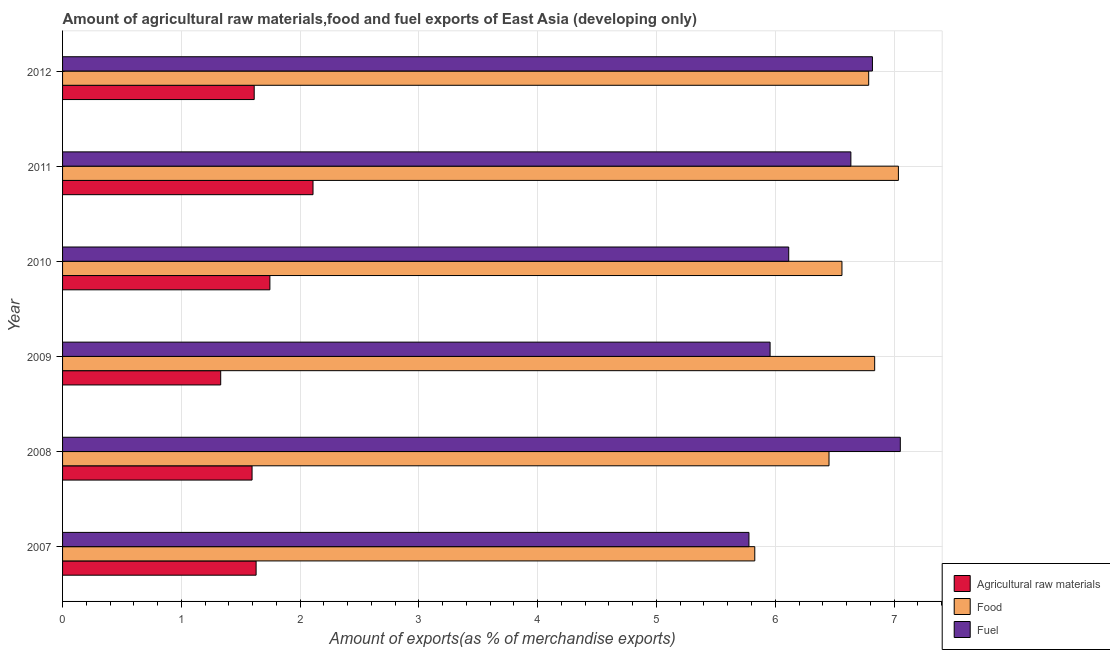How many different coloured bars are there?
Your answer should be very brief. 3. Are the number of bars per tick equal to the number of legend labels?
Offer a terse response. Yes. How many bars are there on the 6th tick from the top?
Your answer should be very brief. 3. In how many cases, is the number of bars for a given year not equal to the number of legend labels?
Offer a very short reply. 0. What is the percentage of raw materials exports in 2009?
Your answer should be compact. 1.33. Across all years, what is the maximum percentage of raw materials exports?
Your response must be concise. 2.11. Across all years, what is the minimum percentage of raw materials exports?
Your answer should be very brief. 1.33. In which year was the percentage of food exports minimum?
Keep it short and to the point. 2007. What is the total percentage of food exports in the graph?
Provide a succinct answer. 39.5. What is the difference between the percentage of food exports in 2010 and the percentage of fuel exports in 2012?
Ensure brevity in your answer.  -0.26. What is the average percentage of fuel exports per year?
Make the answer very short. 6.39. In the year 2012, what is the difference between the percentage of fuel exports and percentage of raw materials exports?
Offer a very short reply. 5.21. What is the ratio of the percentage of food exports in 2008 to that in 2009?
Keep it short and to the point. 0.94. Is the percentage of fuel exports in 2008 less than that in 2012?
Your response must be concise. No. What is the difference between the highest and the second highest percentage of fuel exports?
Your answer should be very brief. 0.23. What is the difference between the highest and the lowest percentage of raw materials exports?
Offer a very short reply. 0.78. Is the sum of the percentage of food exports in 2008 and 2012 greater than the maximum percentage of fuel exports across all years?
Your answer should be very brief. Yes. What does the 3rd bar from the top in 2012 represents?
Offer a terse response. Agricultural raw materials. What does the 1st bar from the bottom in 2007 represents?
Give a very brief answer. Agricultural raw materials. How many bars are there?
Offer a very short reply. 18. Are all the bars in the graph horizontal?
Keep it short and to the point. Yes. What is the difference between two consecutive major ticks on the X-axis?
Provide a succinct answer. 1. Are the values on the major ticks of X-axis written in scientific E-notation?
Offer a terse response. No. Where does the legend appear in the graph?
Keep it short and to the point. Bottom right. How many legend labels are there?
Give a very brief answer. 3. How are the legend labels stacked?
Your answer should be very brief. Vertical. What is the title of the graph?
Your answer should be very brief. Amount of agricultural raw materials,food and fuel exports of East Asia (developing only). What is the label or title of the X-axis?
Offer a terse response. Amount of exports(as % of merchandise exports). What is the Amount of exports(as % of merchandise exports) in Agricultural raw materials in 2007?
Offer a very short reply. 1.63. What is the Amount of exports(as % of merchandise exports) of Food in 2007?
Provide a short and direct response. 5.83. What is the Amount of exports(as % of merchandise exports) in Fuel in 2007?
Your response must be concise. 5.78. What is the Amount of exports(as % of merchandise exports) in Agricultural raw materials in 2008?
Provide a succinct answer. 1.6. What is the Amount of exports(as % of merchandise exports) in Food in 2008?
Keep it short and to the point. 6.45. What is the Amount of exports(as % of merchandise exports) of Fuel in 2008?
Ensure brevity in your answer.  7.05. What is the Amount of exports(as % of merchandise exports) in Agricultural raw materials in 2009?
Your response must be concise. 1.33. What is the Amount of exports(as % of merchandise exports) in Food in 2009?
Make the answer very short. 6.84. What is the Amount of exports(as % of merchandise exports) of Fuel in 2009?
Offer a terse response. 5.96. What is the Amount of exports(as % of merchandise exports) in Agricultural raw materials in 2010?
Give a very brief answer. 1.75. What is the Amount of exports(as % of merchandise exports) in Food in 2010?
Your answer should be very brief. 6.56. What is the Amount of exports(as % of merchandise exports) of Fuel in 2010?
Keep it short and to the point. 6.11. What is the Amount of exports(as % of merchandise exports) of Agricultural raw materials in 2011?
Ensure brevity in your answer.  2.11. What is the Amount of exports(as % of merchandise exports) of Food in 2011?
Provide a short and direct response. 7.04. What is the Amount of exports(as % of merchandise exports) in Fuel in 2011?
Your answer should be very brief. 6.64. What is the Amount of exports(as % of merchandise exports) in Agricultural raw materials in 2012?
Keep it short and to the point. 1.61. What is the Amount of exports(as % of merchandise exports) of Food in 2012?
Keep it short and to the point. 6.79. What is the Amount of exports(as % of merchandise exports) in Fuel in 2012?
Make the answer very short. 6.82. Across all years, what is the maximum Amount of exports(as % of merchandise exports) in Agricultural raw materials?
Offer a very short reply. 2.11. Across all years, what is the maximum Amount of exports(as % of merchandise exports) in Food?
Provide a short and direct response. 7.04. Across all years, what is the maximum Amount of exports(as % of merchandise exports) of Fuel?
Offer a very short reply. 7.05. Across all years, what is the minimum Amount of exports(as % of merchandise exports) in Agricultural raw materials?
Your answer should be very brief. 1.33. Across all years, what is the minimum Amount of exports(as % of merchandise exports) in Food?
Keep it short and to the point. 5.83. Across all years, what is the minimum Amount of exports(as % of merchandise exports) in Fuel?
Offer a very short reply. 5.78. What is the total Amount of exports(as % of merchandise exports) of Agricultural raw materials in the graph?
Make the answer very short. 10.02. What is the total Amount of exports(as % of merchandise exports) in Food in the graph?
Your response must be concise. 39.5. What is the total Amount of exports(as % of merchandise exports) in Fuel in the graph?
Your answer should be very brief. 38.36. What is the difference between the Amount of exports(as % of merchandise exports) in Agricultural raw materials in 2007 and that in 2008?
Provide a short and direct response. 0.03. What is the difference between the Amount of exports(as % of merchandise exports) of Food in 2007 and that in 2008?
Make the answer very short. -0.62. What is the difference between the Amount of exports(as % of merchandise exports) in Fuel in 2007 and that in 2008?
Your response must be concise. -1.27. What is the difference between the Amount of exports(as % of merchandise exports) in Agricultural raw materials in 2007 and that in 2009?
Keep it short and to the point. 0.3. What is the difference between the Amount of exports(as % of merchandise exports) in Food in 2007 and that in 2009?
Give a very brief answer. -1.01. What is the difference between the Amount of exports(as % of merchandise exports) in Fuel in 2007 and that in 2009?
Offer a terse response. -0.18. What is the difference between the Amount of exports(as % of merchandise exports) in Agricultural raw materials in 2007 and that in 2010?
Keep it short and to the point. -0.12. What is the difference between the Amount of exports(as % of merchandise exports) in Food in 2007 and that in 2010?
Offer a terse response. -0.73. What is the difference between the Amount of exports(as % of merchandise exports) in Fuel in 2007 and that in 2010?
Provide a short and direct response. -0.33. What is the difference between the Amount of exports(as % of merchandise exports) of Agricultural raw materials in 2007 and that in 2011?
Your response must be concise. -0.48. What is the difference between the Amount of exports(as % of merchandise exports) in Food in 2007 and that in 2011?
Provide a short and direct response. -1.21. What is the difference between the Amount of exports(as % of merchandise exports) in Fuel in 2007 and that in 2011?
Make the answer very short. -0.86. What is the difference between the Amount of exports(as % of merchandise exports) in Agricultural raw materials in 2007 and that in 2012?
Give a very brief answer. 0.02. What is the difference between the Amount of exports(as % of merchandise exports) of Food in 2007 and that in 2012?
Your answer should be compact. -0.96. What is the difference between the Amount of exports(as % of merchandise exports) of Fuel in 2007 and that in 2012?
Keep it short and to the point. -1.04. What is the difference between the Amount of exports(as % of merchandise exports) in Agricultural raw materials in 2008 and that in 2009?
Your answer should be compact. 0.26. What is the difference between the Amount of exports(as % of merchandise exports) of Food in 2008 and that in 2009?
Your answer should be compact. -0.38. What is the difference between the Amount of exports(as % of merchandise exports) of Fuel in 2008 and that in 2009?
Provide a succinct answer. 1.1. What is the difference between the Amount of exports(as % of merchandise exports) in Agricultural raw materials in 2008 and that in 2010?
Your answer should be compact. -0.15. What is the difference between the Amount of exports(as % of merchandise exports) in Food in 2008 and that in 2010?
Offer a terse response. -0.11. What is the difference between the Amount of exports(as % of merchandise exports) of Fuel in 2008 and that in 2010?
Offer a very short reply. 0.94. What is the difference between the Amount of exports(as % of merchandise exports) of Agricultural raw materials in 2008 and that in 2011?
Provide a short and direct response. -0.51. What is the difference between the Amount of exports(as % of merchandise exports) in Food in 2008 and that in 2011?
Offer a terse response. -0.58. What is the difference between the Amount of exports(as % of merchandise exports) of Fuel in 2008 and that in 2011?
Offer a very short reply. 0.42. What is the difference between the Amount of exports(as % of merchandise exports) in Agricultural raw materials in 2008 and that in 2012?
Your answer should be very brief. -0.02. What is the difference between the Amount of exports(as % of merchandise exports) of Food in 2008 and that in 2012?
Keep it short and to the point. -0.33. What is the difference between the Amount of exports(as % of merchandise exports) in Fuel in 2008 and that in 2012?
Provide a succinct answer. 0.23. What is the difference between the Amount of exports(as % of merchandise exports) in Agricultural raw materials in 2009 and that in 2010?
Your answer should be very brief. -0.41. What is the difference between the Amount of exports(as % of merchandise exports) of Food in 2009 and that in 2010?
Your answer should be compact. 0.28. What is the difference between the Amount of exports(as % of merchandise exports) in Fuel in 2009 and that in 2010?
Provide a succinct answer. -0.16. What is the difference between the Amount of exports(as % of merchandise exports) of Agricultural raw materials in 2009 and that in 2011?
Your response must be concise. -0.78. What is the difference between the Amount of exports(as % of merchandise exports) of Food in 2009 and that in 2011?
Give a very brief answer. -0.2. What is the difference between the Amount of exports(as % of merchandise exports) in Fuel in 2009 and that in 2011?
Your answer should be very brief. -0.68. What is the difference between the Amount of exports(as % of merchandise exports) of Agricultural raw materials in 2009 and that in 2012?
Offer a very short reply. -0.28. What is the difference between the Amount of exports(as % of merchandise exports) in Food in 2009 and that in 2012?
Your answer should be very brief. 0.05. What is the difference between the Amount of exports(as % of merchandise exports) of Fuel in 2009 and that in 2012?
Keep it short and to the point. -0.86. What is the difference between the Amount of exports(as % of merchandise exports) of Agricultural raw materials in 2010 and that in 2011?
Your response must be concise. -0.36. What is the difference between the Amount of exports(as % of merchandise exports) of Food in 2010 and that in 2011?
Provide a succinct answer. -0.48. What is the difference between the Amount of exports(as % of merchandise exports) in Fuel in 2010 and that in 2011?
Give a very brief answer. -0.52. What is the difference between the Amount of exports(as % of merchandise exports) in Agricultural raw materials in 2010 and that in 2012?
Your answer should be compact. 0.13. What is the difference between the Amount of exports(as % of merchandise exports) in Food in 2010 and that in 2012?
Your answer should be compact. -0.23. What is the difference between the Amount of exports(as % of merchandise exports) in Fuel in 2010 and that in 2012?
Provide a short and direct response. -0.7. What is the difference between the Amount of exports(as % of merchandise exports) of Agricultural raw materials in 2011 and that in 2012?
Offer a terse response. 0.5. What is the difference between the Amount of exports(as % of merchandise exports) in Food in 2011 and that in 2012?
Your response must be concise. 0.25. What is the difference between the Amount of exports(as % of merchandise exports) of Fuel in 2011 and that in 2012?
Your answer should be compact. -0.18. What is the difference between the Amount of exports(as % of merchandise exports) in Agricultural raw materials in 2007 and the Amount of exports(as % of merchandise exports) in Food in 2008?
Provide a succinct answer. -4.82. What is the difference between the Amount of exports(as % of merchandise exports) of Agricultural raw materials in 2007 and the Amount of exports(as % of merchandise exports) of Fuel in 2008?
Your response must be concise. -5.42. What is the difference between the Amount of exports(as % of merchandise exports) of Food in 2007 and the Amount of exports(as % of merchandise exports) of Fuel in 2008?
Offer a very short reply. -1.23. What is the difference between the Amount of exports(as % of merchandise exports) in Agricultural raw materials in 2007 and the Amount of exports(as % of merchandise exports) in Food in 2009?
Provide a succinct answer. -5.21. What is the difference between the Amount of exports(as % of merchandise exports) of Agricultural raw materials in 2007 and the Amount of exports(as % of merchandise exports) of Fuel in 2009?
Provide a short and direct response. -4.33. What is the difference between the Amount of exports(as % of merchandise exports) of Food in 2007 and the Amount of exports(as % of merchandise exports) of Fuel in 2009?
Offer a very short reply. -0.13. What is the difference between the Amount of exports(as % of merchandise exports) in Agricultural raw materials in 2007 and the Amount of exports(as % of merchandise exports) in Food in 2010?
Provide a short and direct response. -4.93. What is the difference between the Amount of exports(as % of merchandise exports) of Agricultural raw materials in 2007 and the Amount of exports(as % of merchandise exports) of Fuel in 2010?
Make the answer very short. -4.48. What is the difference between the Amount of exports(as % of merchandise exports) of Food in 2007 and the Amount of exports(as % of merchandise exports) of Fuel in 2010?
Give a very brief answer. -0.29. What is the difference between the Amount of exports(as % of merchandise exports) of Agricultural raw materials in 2007 and the Amount of exports(as % of merchandise exports) of Food in 2011?
Ensure brevity in your answer.  -5.41. What is the difference between the Amount of exports(as % of merchandise exports) in Agricultural raw materials in 2007 and the Amount of exports(as % of merchandise exports) in Fuel in 2011?
Keep it short and to the point. -5.01. What is the difference between the Amount of exports(as % of merchandise exports) of Food in 2007 and the Amount of exports(as % of merchandise exports) of Fuel in 2011?
Offer a terse response. -0.81. What is the difference between the Amount of exports(as % of merchandise exports) of Agricultural raw materials in 2007 and the Amount of exports(as % of merchandise exports) of Food in 2012?
Provide a short and direct response. -5.16. What is the difference between the Amount of exports(as % of merchandise exports) of Agricultural raw materials in 2007 and the Amount of exports(as % of merchandise exports) of Fuel in 2012?
Make the answer very short. -5.19. What is the difference between the Amount of exports(as % of merchandise exports) of Food in 2007 and the Amount of exports(as % of merchandise exports) of Fuel in 2012?
Make the answer very short. -0.99. What is the difference between the Amount of exports(as % of merchandise exports) of Agricultural raw materials in 2008 and the Amount of exports(as % of merchandise exports) of Food in 2009?
Offer a terse response. -5.24. What is the difference between the Amount of exports(as % of merchandise exports) in Agricultural raw materials in 2008 and the Amount of exports(as % of merchandise exports) in Fuel in 2009?
Your response must be concise. -4.36. What is the difference between the Amount of exports(as % of merchandise exports) in Food in 2008 and the Amount of exports(as % of merchandise exports) in Fuel in 2009?
Offer a very short reply. 0.5. What is the difference between the Amount of exports(as % of merchandise exports) of Agricultural raw materials in 2008 and the Amount of exports(as % of merchandise exports) of Food in 2010?
Offer a terse response. -4.97. What is the difference between the Amount of exports(as % of merchandise exports) in Agricultural raw materials in 2008 and the Amount of exports(as % of merchandise exports) in Fuel in 2010?
Give a very brief answer. -4.52. What is the difference between the Amount of exports(as % of merchandise exports) in Food in 2008 and the Amount of exports(as % of merchandise exports) in Fuel in 2010?
Offer a terse response. 0.34. What is the difference between the Amount of exports(as % of merchandise exports) of Agricultural raw materials in 2008 and the Amount of exports(as % of merchandise exports) of Food in 2011?
Offer a very short reply. -5.44. What is the difference between the Amount of exports(as % of merchandise exports) of Agricultural raw materials in 2008 and the Amount of exports(as % of merchandise exports) of Fuel in 2011?
Offer a very short reply. -5.04. What is the difference between the Amount of exports(as % of merchandise exports) of Food in 2008 and the Amount of exports(as % of merchandise exports) of Fuel in 2011?
Your answer should be very brief. -0.18. What is the difference between the Amount of exports(as % of merchandise exports) in Agricultural raw materials in 2008 and the Amount of exports(as % of merchandise exports) in Food in 2012?
Your answer should be compact. -5.19. What is the difference between the Amount of exports(as % of merchandise exports) of Agricultural raw materials in 2008 and the Amount of exports(as % of merchandise exports) of Fuel in 2012?
Provide a succinct answer. -5.22. What is the difference between the Amount of exports(as % of merchandise exports) in Food in 2008 and the Amount of exports(as % of merchandise exports) in Fuel in 2012?
Your answer should be very brief. -0.37. What is the difference between the Amount of exports(as % of merchandise exports) in Agricultural raw materials in 2009 and the Amount of exports(as % of merchandise exports) in Food in 2010?
Give a very brief answer. -5.23. What is the difference between the Amount of exports(as % of merchandise exports) in Agricultural raw materials in 2009 and the Amount of exports(as % of merchandise exports) in Fuel in 2010?
Ensure brevity in your answer.  -4.78. What is the difference between the Amount of exports(as % of merchandise exports) in Food in 2009 and the Amount of exports(as % of merchandise exports) in Fuel in 2010?
Provide a short and direct response. 0.72. What is the difference between the Amount of exports(as % of merchandise exports) in Agricultural raw materials in 2009 and the Amount of exports(as % of merchandise exports) in Food in 2011?
Your answer should be compact. -5.71. What is the difference between the Amount of exports(as % of merchandise exports) of Agricultural raw materials in 2009 and the Amount of exports(as % of merchandise exports) of Fuel in 2011?
Provide a succinct answer. -5.31. What is the difference between the Amount of exports(as % of merchandise exports) of Food in 2009 and the Amount of exports(as % of merchandise exports) of Fuel in 2011?
Ensure brevity in your answer.  0.2. What is the difference between the Amount of exports(as % of merchandise exports) in Agricultural raw materials in 2009 and the Amount of exports(as % of merchandise exports) in Food in 2012?
Give a very brief answer. -5.46. What is the difference between the Amount of exports(as % of merchandise exports) in Agricultural raw materials in 2009 and the Amount of exports(as % of merchandise exports) in Fuel in 2012?
Ensure brevity in your answer.  -5.49. What is the difference between the Amount of exports(as % of merchandise exports) in Food in 2009 and the Amount of exports(as % of merchandise exports) in Fuel in 2012?
Make the answer very short. 0.02. What is the difference between the Amount of exports(as % of merchandise exports) of Agricultural raw materials in 2010 and the Amount of exports(as % of merchandise exports) of Food in 2011?
Offer a very short reply. -5.29. What is the difference between the Amount of exports(as % of merchandise exports) of Agricultural raw materials in 2010 and the Amount of exports(as % of merchandise exports) of Fuel in 2011?
Give a very brief answer. -4.89. What is the difference between the Amount of exports(as % of merchandise exports) of Food in 2010 and the Amount of exports(as % of merchandise exports) of Fuel in 2011?
Keep it short and to the point. -0.08. What is the difference between the Amount of exports(as % of merchandise exports) in Agricultural raw materials in 2010 and the Amount of exports(as % of merchandise exports) in Food in 2012?
Offer a terse response. -5.04. What is the difference between the Amount of exports(as % of merchandise exports) of Agricultural raw materials in 2010 and the Amount of exports(as % of merchandise exports) of Fuel in 2012?
Your answer should be very brief. -5.07. What is the difference between the Amount of exports(as % of merchandise exports) of Food in 2010 and the Amount of exports(as % of merchandise exports) of Fuel in 2012?
Your answer should be compact. -0.26. What is the difference between the Amount of exports(as % of merchandise exports) in Agricultural raw materials in 2011 and the Amount of exports(as % of merchandise exports) in Food in 2012?
Ensure brevity in your answer.  -4.68. What is the difference between the Amount of exports(as % of merchandise exports) of Agricultural raw materials in 2011 and the Amount of exports(as % of merchandise exports) of Fuel in 2012?
Provide a succinct answer. -4.71. What is the difference between the Amount of exports(as % of merchandise exports) of Food in 2011 and the Amount of exports(as % of merchandise exports) of Fuel in 2012?
Keep it short and to the point. 0.22. What is the average Amount of exports(as % of merchandise exports) in Agricultural raw materials per year?
Your answer should be very brief. 1.67. What is the average Amount of exports(as % of merchandise exports) in Food per year?
Provide a short and direct response. 6.58. What is the average Amount of exports(as % of merchandise exports) of Fuel per year?
Your answer should be compact. 6.39. In the year 2007, what is the difference between the Amount of exports(as % of merchandise exports) in Agricultural raw materials and Amount of exports(as % of merchandise exports) in Food?
Provide a succinct answer. -4.2. In the year 2007, what is the difference between the Amount of exports(as % of merchandise exports) of Agricultural raw materials and Amount of exports(as % of merchandise exports) of Fuel?
Offer a terse response. -4.15. In the year 2007, what is the difference between the Amount of exports(as % of merchandise exports) in Food and Amount of exports(as % of merchandise exports) in Fuel?
Your answer should be compact. 0.05. In the year 2008, what is the difference between the Amount of exports(as % of merchandise exports) in Agricultural raw materials and Amount of exports(as % of merchandise exports) in Food?
Offer a very short reply. -4.86. In the year 2008, what is the difference between the Amount of exports(as % of merchandise exports) in Agricultural raw materials and Amount of exports(as % of merchandise exports) in Fuel?
Make the answer very short. -5.46. In the year 2008, what is the difference between the Amount of exports(as % of merchandise exports) in Food and Amount of exports(as % of merchandise exports) in Fuel?
Give a very brief answer. -0.6. In the year 2009, what is the difference between the Amount of exports(as % of merchandise exports) in Agricultural raw materials and Amount of exports(as % of merchandise exports) in Food?
Provide a succinct answer. -5.51. In the year 2009, what is the difference between the Amount of exports(as % of merchandise exports) in Agricultural raw materials and Amount of exports(as % of merchandise exports) in Fuel?
Ensure brevity in your answer.  -4.63. In the year 2009, what is the difference between the Amount of exports(as % of merchandise exports) of Food and Amount of exports(as % of merchandise exports) of Fuel?
Provide a succinct answer. 0.88. In the year 2010, what is the difference between the Amount of exports(as % of merchandise exports) of Agricultural raw materials and Amount of exports(as % of merchandise exports) of Food?
Provide a succinct answer. -4.82. In the year 2010, what is the difference between the Amount of exports(as % of merchandise exports) in Agricultural raw materials and Amount of exports(as % of merchandise exports) in Fuel?
Offer a terse response. -4.37. In the year 2010, what is the difference between the Amount of exports(as % of merchandise exports) in Food and Amount of exports(as % of merchandise exports) in Fuel?
Your answer should be compact. 0.45. In the year 2011, what is the difference between the Amount of exports(as % of merchandise exports) in Agricultural raw materials and Amount of exports(as % of merchandise exports) in Food?
Make the answer very short. -4.93. In the year 2011, what is the difference between the Amount of exports(as % of merchandise exports) in Agricultural raw materials and Amount of exports(as % of merchandise exports) in Fuel?
Provide a succinct answer. -4.53. In the year 2011, what is the difference between the Amount of exports(as % of merchandise exports) in Food and Amount of exports(as % of merchandise exports) in Fuel?
Your answer should be very brief. 0.4. In the year 2012, what is the difference between the Amount of exports(as % of merchandise exports) in Agricultural raw materials and Amount of exports(as % of merchandise exports) in Food?
Provide a succinct answer. -5.17. In the year 2012, what is the difference between the Amount of exports(as % of merchandise exports) in Agricultural raw materials and Amount of exports(as % of merchandise exports) in Fuel?
Your answer should be very brief. -5.2. In the year 2012, what is the difference between the Amount of exports(as % of merchandise exports) of Food and Amount of exports(as % of merchandise exports) of Fuel?
Keep it short and to the point. -0.03. What is the ratio of the Amount of exports(as % of merchandise exports) in Agricultural raw materials in 2007 to that in 2008?
Offer a terse response. 1.02. What is the ratio of the Amount of exports(as % of merchandise exports) of Food in 2007 to that in 2008?
Provide a succinct answer. 0.9. What is the ratio of the Amount of exports(as % of merchandise exports) in Fuel in 2007 to that in 2008?
Offer a terse response. 0.82. What is the ratio of the Amount of exports(as % of merchandise exports) of Agricultural raw materials in 2007 to that in 2009?
Your response must be concise. 1.22. What is the ratio of the Amount of exports(as % of merchandise exports) in Food in 2007 to that in 2009?
Provide a succinct answer. 0.85. What is the ratio of the Amount of exports(as % of merchandise exports) of Fuel in 2007 to that in 2009?
Provide a short and direct response. 0.97. What is the ratio of the Amount of exports(as % of merchandise exports) of Agricultural raw materials in 2007 to that in 2010?
Your answer should be compact. 0.93. What is the ratio of the Amount of exports(as % of merchandise exports) of Food in 2007 to that in 2010?
Offer a very short reply. 0.89. What is the ratio of the Amount of exports(as % of merchandise exports) in Fuel in 2007 to that in 2010?
Offer a very short reply. 0.95. What is the ratio of the Amount of exports(as % of merchandise exports) in Agricultural raw materials in 2007 to that in 2011?
Ensure brevity in your answer.  0.77. What is the ratio of the Amount of exports(as % of merchandise exports) in Food in 2007 to that in 2011?
Your answer should be compact. 0.83. What is the ratio of the Amount of exports(as % of merchandise exports) of Fuel in 2007 to that in 2011?
Your answer should be compact. 0.87. What is the ratio of the Amount of exports(as % of merchandise exports) in Agricultural raw materials in 2007 to that in 2012?
Ensure brevity in your answer.  1.01. What is the ratio of the Amount of exports(as % of merchandise exports) of Food in 2007 to that in 2012?
Your response must be concise. 0.86. What is the ratio of the Amount of exports(as % of merchandise exports) in Fuel in 2007 to that in 2012?
Ensure brevity in your answer.  0.85. What is the ratio of the Amount of exports(as % of merchandise exports) of Agricultural raw materials in 2008 to that in 2009?
Offer a very short reply. 1.2. What is the ratio of the Amount of exports(as % of merchandise exports) in Food in 2008 to that in 2009?
Offer a terse response. 0.94. What is the ratio of the Amount of exports(as % of merchandise exports) of Fuel in 2008 to that in 2009?
Your response must be concise. 1.18. What is the ratio of the Amount of exports(as % of merchandise exports) of Agricultural raw materials in 2008 to that in 2010?
Your response must be concise. 0.91. What is the ratio of the Amount of exports(as % of merchandise exports) of Food in 2008 to that in 2010?
Provide a succinct answer. 0.98. What is the ratio of the Amount of exports(as % of merchandise exports) in Fuel in 2008 to that in 2010?
Ensure brevity in your answer.  1.15. What is the ratio of the Amount of exports(as % of merchandise exports) of Agricultural raw materials in 2008 to that in 2011?
Offer a very short reply. 0.76. What is the ratio of the Amount of exports(as % of merchandise exports) of Food in 2008 to that in 2011?
Your answer should be very brief. 0.92. What is the ratio of the Amount of exports(as % of merchandise exports) in Fuel in 2008 to that in 2011?
Your response must be concise. 1.06. What is the ratio of the Amount of exports(as % of merchandise exports) in Agricultural raw materials in 2008 to that in 2012?
Offer a very short reply. 0.99. What is the ratio of the Amount of exports(as % of merchandise exports) in Food in 2008 to that in 2012?
Give a very brief answer. 0.95. What is the ratio of the Amount of exports(as % of merchandise exports) in Fuel in 2008 to that in 2012?
Offer a terse response. 1.03. What is the ratio of the Amount of exports(as % of merchandise exports) in Agricultural raw materials in 2009 to that in 2010?
Give a very brief answer. 0.76. What is the ratio of the Amount of exports(as % of merchandise exports) in Food in 2009 to that in 2010?
Keep it short and to the point. 1.04. What is the ratio of the Amount of exports(as % of merchandise exports) in Fuel in 2009 to that in 2010?
Offer a very short reply. 0.97. What is the ratio of the Amount of exports(as % of merchandise exports) in Agricultural raw materials in 2009 to that in 2011?
Your answer should be very brief. 0.63. What is the ratio of the Amount of exports(as % of merchandise exports) in Food in 2009 to that in 2011?
Your answer should be compact. 0.97. What is the ratio of the Amount of exports(as % of merchandise exports) in Fuel in 2009 to that in 2011?
Keep it short and to the point. 0.9. What is the ratio of the Amount of exports(as % of merchandise exports) in Agricultural raw materials in 2009 to that in 2012?
Offer a very short reply. 0.83. What is the ratio of the Amount of exports(as % of merchandise exports) in Food in 2009 to that in 2012?
Your answer should be very brief. 1.01. What is the ratio of the Amount of exports(as % of merchandise exports) of Fuel in 2009 to that in 2012?
Give a very brief answer. 0.87. What is the ratio of the Amount of exports(as % of merchandise exports) of Agricultural raw materials in 2010 to that in 2011?
Offer a very short reply. 0.83. What is the ratio of the Amount of exports(as % of merchandise exports) of Food in 2010 to that in 2011?
Your response must be concise. 0.93. What is the ratio of the Amount of exports(as % of merchandise exports) of Fuel in 2010 to that in 2011?
Offer a very short reply. 0.92. What is the ratio of the Amount of exports(as % of merchandise exports) in Agricultural raw materials in 2010 to that in 2012?
Provide a short and direct response. 1.08. What is the ratio of the Amount of exports(as % of merchandise exports) in Food in 2010 to that in 2012?
Give a very brief answer. 0.97. What is the ratio of the Amount of exports(as % of merchandise exports) in Fuel in 2010 to that in 2012?
Ensure brevity in your answer.  0.9. What is the ratio of the Amount of exports(as % of merchandise exports) in Agricultural raw materials in 2011 to that in 2012?
Make the answer very short. 1.31. What is the ratio of the Amount of exports(as % of merchandise exports) of Food in 2011 to that in 2012?
Provide a short and direct response. 1.04. What is the ratio of the Amount of exports(as % of merchandise exports) of Fuel in 2011 to that in 2012?
Offer a very short reply. 0.97. What is the difference between the highest and the second highest Amount of exports(as % of merchandise exports) of Agricultural raw materials?
Your response must be concise. 0.36. What is the difference between the highest and the second highest Amount of exports(as % of merchandise exports) of Food?
Give a very brief answer. 0.2. What is the difference between the highest and the second highest Amount of exports(as % of merchandise exports) in Fuel?
Provide a short and direct response. 0.23. What is the difference between the highest and the lowest Amount of exports(as % of merchandise exports) of Agricultural raw materials?
Give a very brief answer. 0.78. What is the difference between the highest and the lowest Amount of exports(as % of merchandise exports) of Food?
Offer a terse response. 1.21. What is the difference between the highest and the lowest Amount of exports(as % of merchandise exports) of Fuel?
Provide a succinct answer. 1.27. 